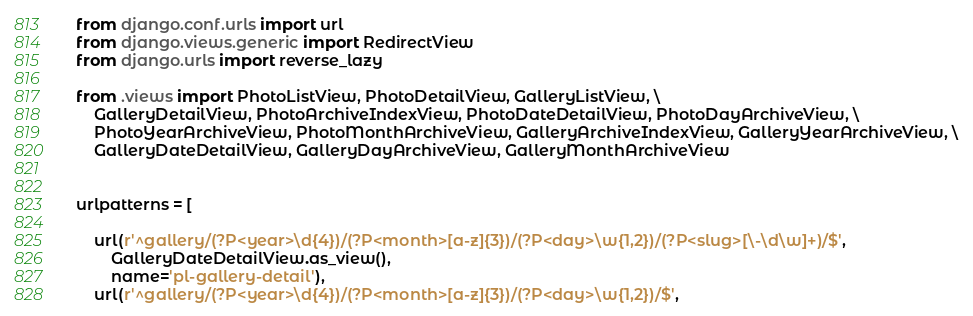<code> <loc_0><loc_0><loc_500><loc_500><_Python_>from django.conf.urls import url
from django.views.generic import RedirectView
from django.urls import reverse_lazy

from .views import PhotoListView, PhotoDetailView, GalleryListView, \
    GalleryDetailView, PhotoArchiveIndexView, PhotoDateDetailView, PhotoDayArchiveView, \
    PhotoYearArchiveView, PhotoMonthArchiveView, GalleryArchiveIndexView, GalleryYearArchiveView, \
    GalleryDateDetailView, GalleryDayArchiveView, GalleryMonthArchiveView


urlpatterns = [

    url(r'^gallery/(?P<year>\d{4})/(?P<month>[a-z]{3})/(?P<day>\w{1,2})/(?P<slug>[\-\d\w]+)/$',
        GalleryDateDetailView.as_view(),
        name='pl-gallery-detail'),
    url(r'^gallery/(?P<year>\d{4})/(?P<month>[a-z]{3})/(?P<day>\w{1,2})/$',</code> 